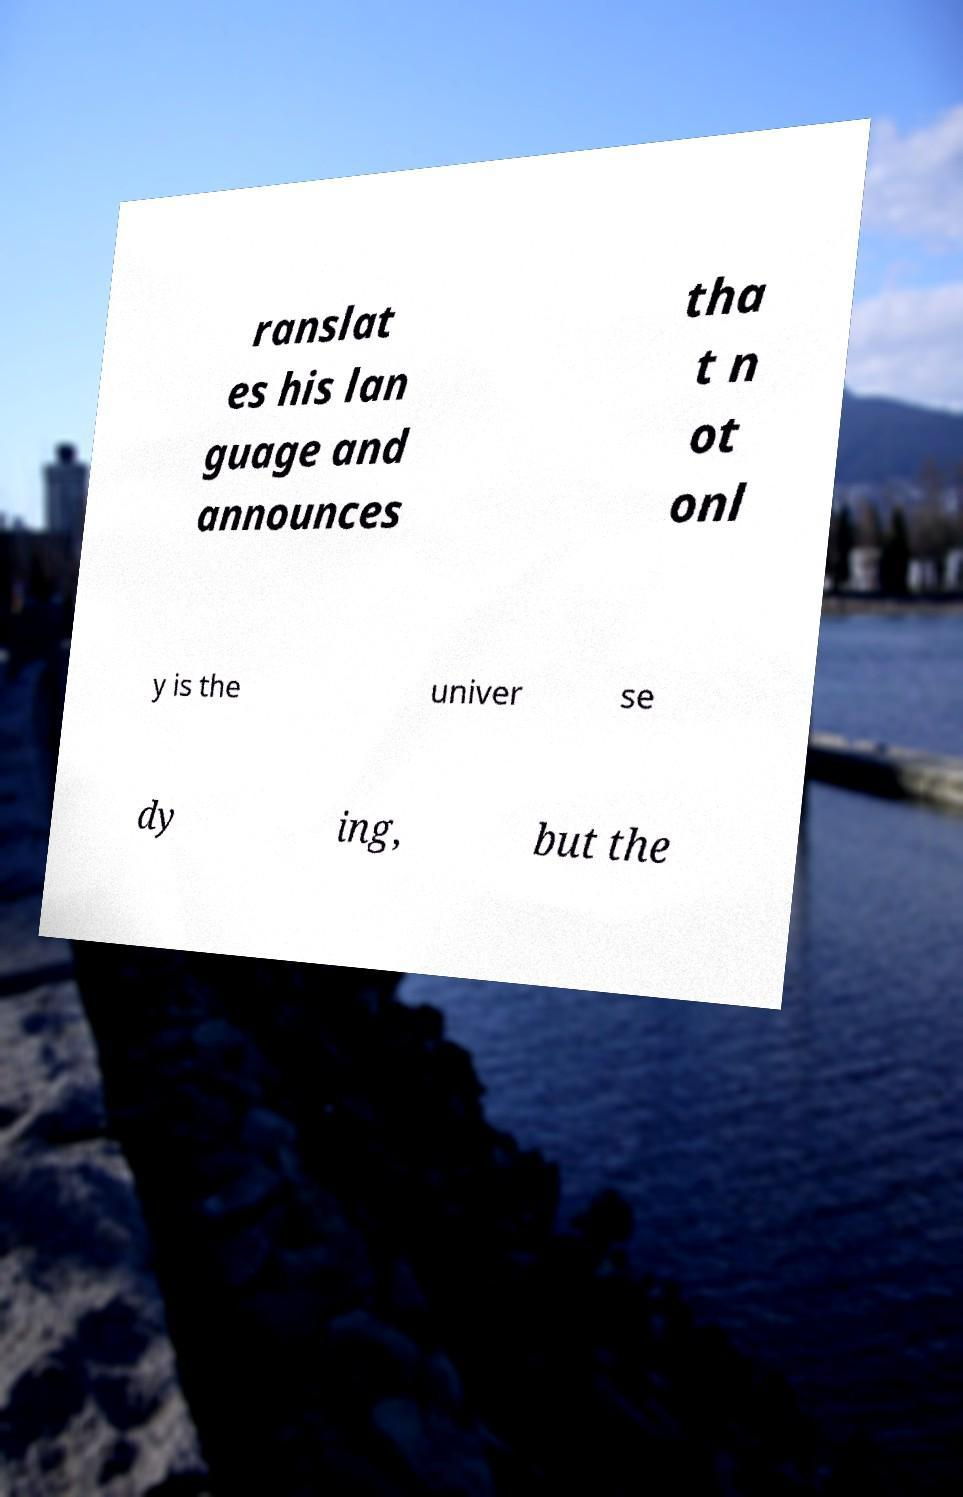Can you read and provide the text displayed in the image?This photo seems to have some interesting text. Can you extract and type it out for me? ranslat es his lan guage and announces tha t n ot onl y is the univer se dy ing, but the 